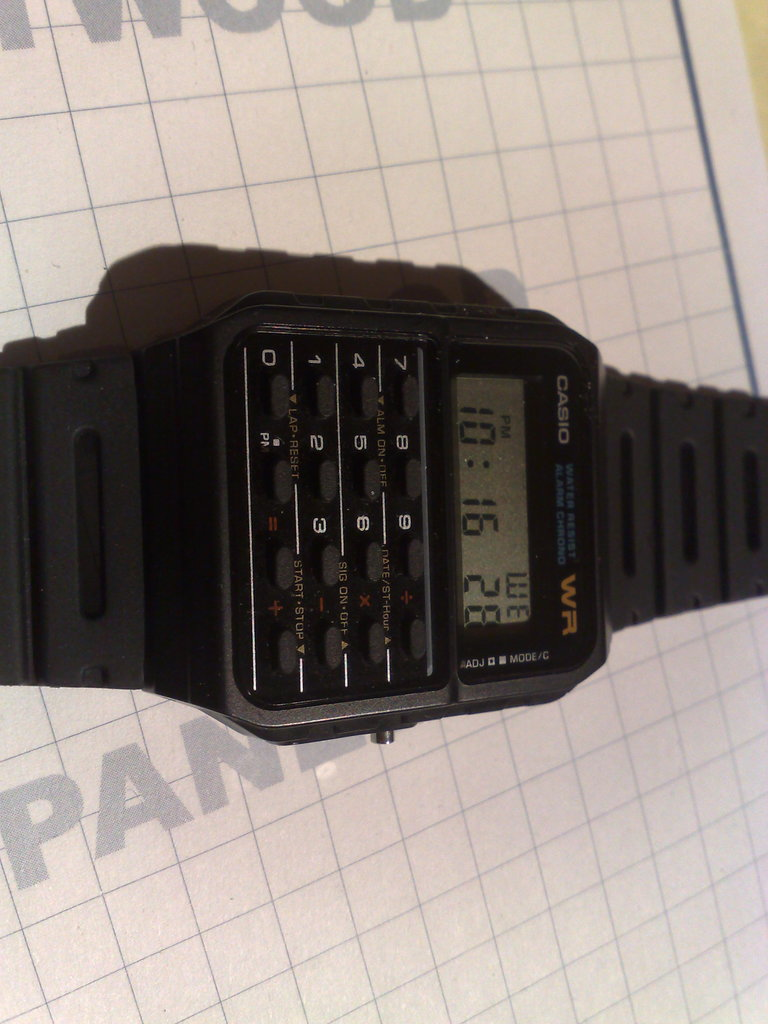How might this object have cultural or historical significance? This CASIO calculator watch became an iconic product of the 1980s, representing the era's fascination with portable electronics and the merging of utility with personal fashion. Can you tell me more about its design and user experience? Certainly! The watch features a compact, practical design with a small screen for the digital display and a series of miniature buttons for calculator functions. It prioritizes functionality and was designed for convenience, though users with larger fingers may find the buttons challenging to operate. 